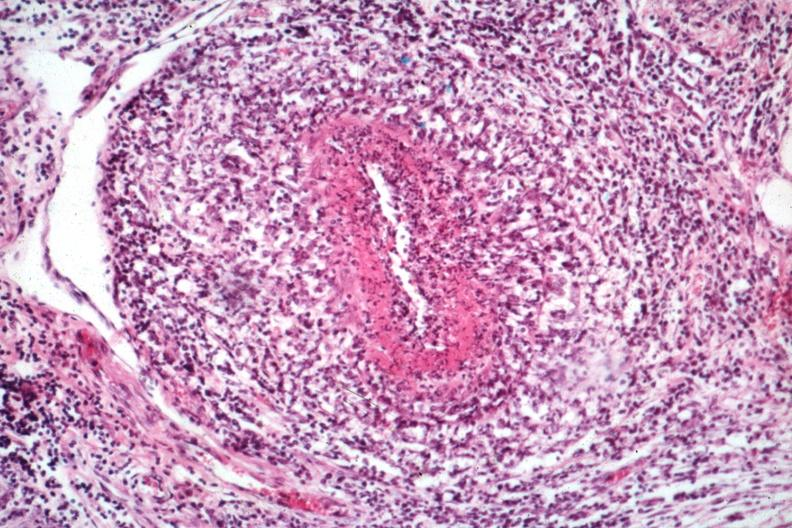what is present?
Answer the question using a single word or phrase. Rheumatoid arthritis with vasculitis 